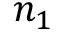<formula> <loc_0><loc_0><loc_500><loc_500>n _ { 1 }</formula> 